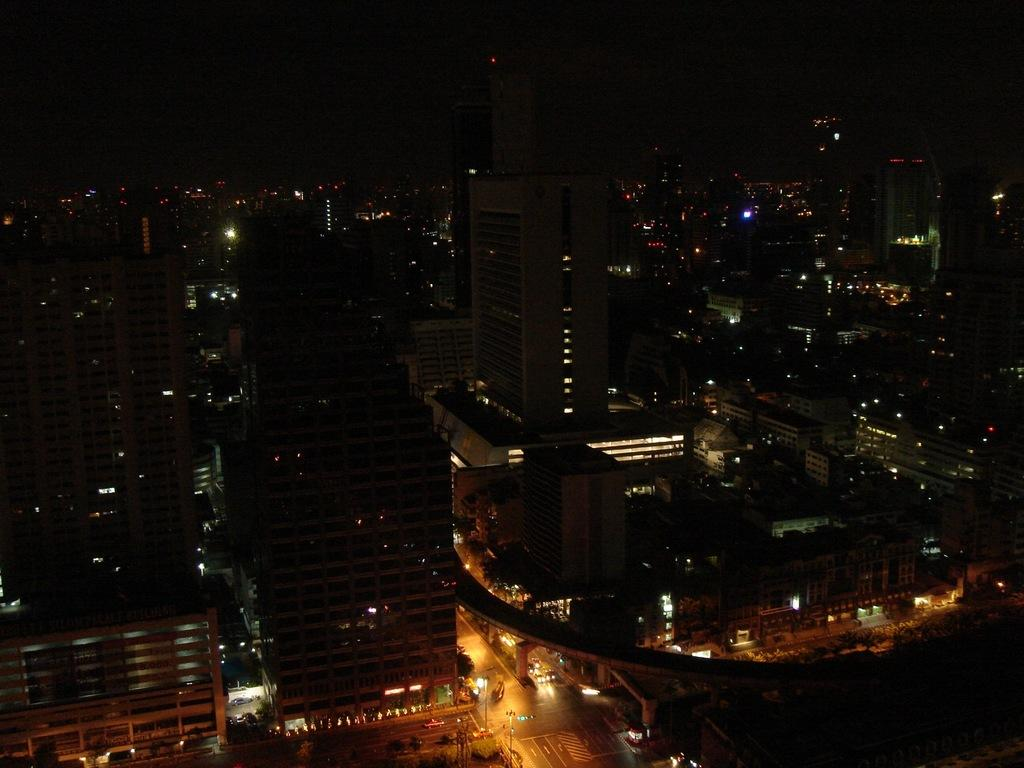What can be seen on the road in the image? There are vehicles on the road in the image. What helps regulate the traffic in the image? There are traffic lights in the image. What structures are present to provide illumination? There are light poles in the image. What type of man-made structures are visible in the image? There are buildings in the image. Can you hear a whistle in the image? There is no mention of a whistle in the image, so it cannot be heard. Is there a yard visible in the image? The provided facts do not mention a yard, so it is not visible in the image. 